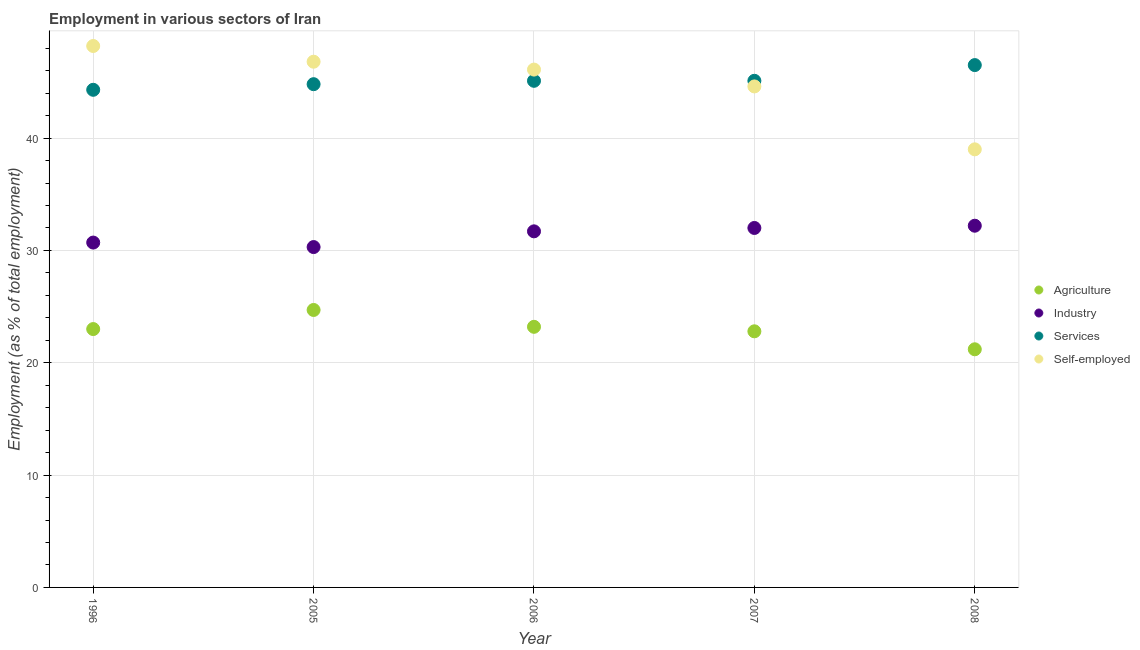Is the number of dotlines equal to the number of legend labels?
Provide a succinct answer. Yes. What is the percentage of workers in services in 2007?
Ensure brevity in your answer.  45.1. Across all years, what is the maximum percentage of workers in agriculture?
Your answer should be compact. 24.7. Across all years, what is the minimum percentage of workers in services?
Your answer should be compact. 44.3. What is the total percentage of workers in agriculture in the graph?
Your answer should be very brief. 114.9. What is the difference between the percentage of workers in services in 1996 and that in 2008?
Provide a succinct answer. -2.2. What is the difference between the percentage of workers in industry in 2006 and the percentage of workers in services in 2008?
Provide a short and direct response. -14.8. What is the average percentage of workers in services per year?
Give a very brief answer. 45.16. In the year 2006, what is the difference between the percentage of workers in services and percentage of workers in industry?
Offer a very short reply. 13.4. In how many years, is the percentage of workers in agriculture greater than 36 %?
Keep it short and to the point. 0. What is the ratio of the percentage of workers in services in 1996 to that in 2006?
Your answer should be compact. 0.98. What is the difference between the highest and the second highest percentage of workers in industry?
Provide a succinct answer. 0.2. What is the difference between the highest and the lowest percentage of workers in industry?
Offer a terse response. 1.9. In how many years, is the percentage of workers in industry greater than the average percentage of workers in industry taken over all years?
Offer a terse response. 3. Is the sum of the percentage of workers in industry in 2005 and 2008 greater than the maximum percentage of self employed workers across all years?
Your response must be concise. Yes. Is it the case that in every year, the sum of the percentage of self employed workers and percentage of workers in industry is greater than the sum of percentage of workers in services and percentage of workers in agriculture?
Offer a terse response. Yes. Is it the case that in every year, the sum of the percentage of workers in agriculture and percentage of workers in industry is greater than the percentage of workers in services?
Give a very brief answer. Yes. How many dotlines are there?
Offer a very short reply. 4. Does the graph contain any zero values?
Give a very brief answer. No. Where does the legend appear in the graph?
Your answer should be very brief. Center right. What is the title of the graph?
Your response must be concise. Employment in various sectors of Iran. Does "WFP" appear as one of the legend labels in the graph?
Provide a succinct answer. No. What is the label or title of the X-axis?
Your answer should be very brief. Year. What is the label or title of the Y-axis?
Keep it short and to the point. Employment (as % of total employment). What is the Employment (as % of total employment) in Industry in 1996?
Provide a succinct answer. 30.7. What is the Employment (as % of total employment) in Services in 1996?
Give a very brief answer. 44.3. What is the Employment (as % of total employment) of Self-employed in 1996?
Your answer should be very brief. 48.2. What is the Employment (as % of total employment) of Agriculture in 2005?
Keep it short and to the point. 24.7. What is the Employment (as % of total employment) of Industry in 2005?
Give a very brief answer. 30.3. What is the Employment (as % of total employment) of Services in 2005?
Offer a terse response. 44.8. What is the Employment (as % of total employment) in Self-employed in 2005?
Your response must be concise. 46.8. What is the Employment (as % of total employment) of Agriculture in 2006?
Provide a short and direct response. 23.2. What is the Employment (as % of total employment) of Industry in 2006?
Provide a short and direct response. 31.7. What is the Employment (as % of total employment) of Services in 2006?
Ensure brevity in your answer.  45.1. What is the Employment (as % of total employment) of Self-employed in 2006?
Provide a short and direct response. 46.1. What is the Employment (as % of total employment) in Agriculture in 2007?
Your response must be concise. 22.8. What is the Employment (as % of total employment) in Services in 2007?
Provide a succinct answer. 45.1. What is the Employment (as % of total employment) of Self-employed in 2007?
Keep it short and to the point. 44.6. What is the Employment (as % of total employment) in Agriculture in 2008?
Ensure brevity in your answer.  21.2. What is the Employment (as % of total employment) in Industry in 2008?
Give a very brief answer. 32.2. What is the Employment (as % of total employment) of Services in 2008?
Offer a terse response. 46.5. Across all years, what is the maximum Employment (as % of total employment) of Agriculture?
Ensure brevity in your answer.  24.7. Across all years, what is the maximum Employment (as % of total employment) of Industry?
Your answer should be compact. 32.2. Across all years, what is the maximum Employment (as % of total employment) of Services?
Offer a terse response. 46.5. Across all years, what is the maximum Employment (as % of total employment) in Self-employed?
Your answer should be compact. 48.2. Across all years, what is the minimum Employment (as % of total employment) in Agriculture?
Give a very brief answer. 21.2. Across all years, what is the minimum Employment (as % of total employment) of Industry?
Provide a succinct answer. 30.3. Across all years, what is the minimum Employment (as % of total employment) of Services?
Give a very brief answer. 44.3. Across all years, what is the minimum Employment (as % of total employment) of Self-employed?
Offer a very short reply. 39. What is the total Employment (as % of total employment) of Agriculture in the graph?
Offer a terse response. 114.9. What is the total Employment (as % of total employment) in Industry in the graph?
Make the answer very short. 156.9. What is the total Employment (as % of total employment) of Services in the graph?
Your response must be concise. 225.8. What is the total Employment (as % of total employment) of Self-employed in the graph?
Provide a succinct answer. 224.7. What is the difference between the Employment (as % of total employment) of Services in 1996 and that in 2005?
Your response must be concise. -0.5. What is the difference between the Employment (as % of total employment) in Self-employed in 1996 and that in 2005?
Provide a succinct answer. 1.4. What is the difference between the Employment (as % of total employment) of Self-employed in 1996 and that in 2006?
Ensure brevity in your answer.  2.1. What is the difference between the Employment (as % of total employment) in Agriculture in 1996 and that in 2007?
Make the answer very short. 0.2. What is the difference between the Employment (as % of total employment) of Agriculture in 1996 and that in 2008?
Give a very brief answer. 1.8. What is the difference between the Employment (as % of total employment) of Industry in 2005 and that in 2006?
Keep it short and to the point. -1.4. What is the difference between the Employment (as % of total employment) of Agriculture in 2005 and that in 2007?
Your response must be concise. 1.9. What is the difference between the Employment (as % of total employment) in Industry in 2005 and that in 2007?
Ensure brevity in your answer.  -1.7. What is the difference between the Employment (as % of total employment) of Self-employed in 2005 and that in 2007?
Provide a succinct answer. 2.2. What is the difference between the Employment (as % of total employment) of Self-employed in 2005 and that in 2008?
Give a very brief answer. 7.8. What is the difference between the Employment (as % of total employment) in Agriculture in 2006 and that in 2007?
Provide a short and direct response. 0.4. What is the difference between the Employment (as % of total employment) in Industry in 2006 and that in 2007?
Your answer should be compact. -0.3. What is the difference between the Employment (as % of total employment) of Self-employed in 2006 and that in 2007?
Provide a short and direct response. 1.5. What is the difference between the Employment (as % of total employment) of Services in 2006 and that in 2008?
Keep it short and to the point. -1.4. What is the difference between the Employment (as % of total employment) in Industry in 2007 and that in 2008?
Make the answer very short. -0.2. What is the difference between the Employment (as % of total employment) in Agriculture in 1996 and the Employment (as % of total employment) in Services in 2005?
Provide a short and direct response. -21.8. What is the difference between the Employment (as % of total employment) of Agriculture in 1996 and the Employment (as % of total employment) of Self-employed in 2005?
Make the answer very short. -23.8. What is the difference between the Employment (as % of total employment) of Industry in 1996 and the Employment (as % of total employment) of Services in 2005?
Offer a terse response. -14.1. What is the difference between the Employment (as % of total employment) of Industry in 1996 and the Employment (as % of total employment) of Self-employed in 2005?
Give a very brief answer. -16.1. What is the difference between the Employment (as % of total employment) in Services in 1996 and the Employment (as % of total employment) in Self-employed in 2005?
Your answer should be compact. -2.5. What is the difference between the Employment (as % of total employment) in Agriculture in 1996 and the Employment (as % of total employment) in Services in 2006?
Ensure brevity in your answer.  -22.1. What is the difference between the Employment (as % of total employment) in Agriculture in 1996 and the Employment (as % of total employment) in Self-employed in 2006?
Your answer should be compact. -23.1. What is the difference between the Employment (as % of total employment) in Industry in 1996 and the Employment (as % of total employment) in Services in 2006?
Provide a succinct answer. -14.4. What is the difference between the Employment (as % of total employment) in Industry in 1996 and the Employment (as % of total employment) in Self-employed in 2006?
Offer a terse response. -15.4. What is the difference between the Employment (as % of total employment) of Services in 1996 and the Employment (as % of total employment) of Self-employed in 2006?
Keep it short and to the point. -1.8. What is the difference between the Employment (as % of total employment) of Agriculture in 1996 and the Employment (as % of total employment) of Services in 2007?
Give a very brief answer. -22.1. What is the difference between the Employment (as % of total employment) of Agriculture in 1996 and the Employment (as % of total employment) of Self-employed in 2007?
Provide a succinct answer. -21.6. What is the difference between the Employment (as % of total employment) in Industry in 1996 and the Employment (as % of total employment) in Services in 2007?
Offer a very short reply. -14.4. What is the difference between the Employment (as % of total employment) of Industry in 1996 and the Employment (as % of total employment) of Self-employed in 2007?
Keep it short and to the point. -13.9. What is the difference between the Employment (as % of total employment) in Services in 1996 and the Employment (as % of total employment) in Self-employed in 2007?
Give a very brief answer. -0.3. What is the difference between the Employment (as % of total employment) in Agriculture in 1996 and the Employment (as % of total employment) in Industry in 2008?
Your response must be concise. -9.2. What is the difference between the Employment (as % of total employment) in Agriculture in 1996 and the Employment (as % of total employment) in Services in 2008?
Provide a short and direct response. -23.5. What is the difference between the Employment (as % of total employment) of Industry in 1996 and the Employment (as % of total employment) of Services in 2008?
Your answer should be compact. -15.8. What is the difference between the Employment (as % of total employment) of Industry in 1996 and the Employment (as % of total employment) of Self-employed in 2008?
Your answer should be compact. -8.3. What is the difference between the Employment (as % of total employment) in Services in 1996 and the Employment (as % of total employment) in Self-employed in 2008?
Your answer should be very brief. 5.3. What is the difference between the Employment (as % of total employment) in Agriculture in 2005 and the Employment (as % of total employment) in Services in 2006?
Provide a succinct answer. -20.4. What is the difference between the Employment (as % of total employment) in Agriculture in 2005 and the Employment (as % of total employment) in Self-employed in 2006?
Provide a short and direct response. -21.4. What is the difference between the Employment (as % of total employment) of Industry in 2005 and the Employment (as % of total employment) of Services in 2006?
Make the answer very short. -14.8. What is the difference between the Employment (as % of total employment) of Industry in 2005 and the Employment (as % of total employment) of Self-employed in 2006?
Make the answer very short. -15.8. What is the difference between the Employment (as % of total employment) in Agriculture in 2005 and the Employment (as % of total employment) in Services in 2007?
Keep it short and to the point. -20.4. What is the difference between the Employment (as % of total employment) of Agriculture in 2005 and the Employment (as % of total employment) of Self-employed in 2007?
Your answer should be compact. -19.9. What is the difference between the Employment (as % of total employment) of Industry in 2005 and the Employment (as % of total employment) of Services in 2007?
Offer a terse response. -14.8. What is the difference between the Employment (as % of total employment) of Industry in 2005 and the Employment (as % of total employment) of Self-employed in 2007?
Provide a succinct answer. -14.3. What is the difference between the Employment (as % of total employment) of Services in 2005 and the Employment (as % of total employment) of Self-employed in 2007?
Provide a succinct answer. 0.2. What is the difference between the Employment (as % of total employment) in Agriculture in 2005 and the Employment (as % of total employment) in Industry in 2008?
Provide a succinct answer. -7.5. What is the difference between the Employment (as % of total employment) in Agriculture in 2005 and the Employment (as % of total employment) in Services in 2008?
Ensure brevity in your answer.  -21.8. What is the difference between the Employment (as % of total employment) of Agriculture in 2005 and the Employment (as % of total employment) of Self-employed in 2008?
Keep it short and to the point. -14.3. What is the difference between the Employment (as % of total employment) in Industry in 2005 and the Employment (as % of total employment) in Services in 2008?
Provide a short and direct response. -16.2. What is the difference between the Employment (as % of total employment) of Industry in 2005 and the Employment (as % of total employment) of Self-employed in 2008?
Ensure brevity in your answer.  -8.7. What is the difference between the Employment (as % of total employment) of Agriculture in 2006 and the Employment (as % of total employment) of Services in 2007?
Your response must be concise. -21.9. What is the difference between the Employment (as % of total employment) in Agriculture in 2006 and the Employment (as % of total employment) in Self-employed in 2007?
Your answer should be very brief. -21.4. What is the difference between the Employment (as % of total employment) of Industry in 2006 and the Employment (as % of total employment) of Self-employed in 2007?
Make the answer very short. -12.9. What is the difference between the Employment (as % of total employment) in Services in 2006 and the Employment (as % of total employment) in Self-employed in 2007?
Offer a very short reply. 0.5. What is the difference between the Employment (as % of total employment) in Agriculture in 2006 and the Employment (as % of total employment) in Industry in 2008?
Offer a very short reply. -9. What is the difference between the Employment (as % of total employment) of Agriculture in 2006 and the Employment (as % of total employment) of Services in 2008?
Offer a terse response. -23.3. What is the difference between the Employment (as % of total employment) of Agriculture in 2006 and the Employment (as % of total employment) of Self-employed in 2008?
Keep it short and to the point. -15.8. What is the difference between the Employment (as % of total employment) of Industry in 2006 and the Employment (as % of total employment) of Services in 2008?
Your response must be concise. -14.8. What is the difference between the Employment (as % of total employment) of Agriculture in 2007 and the Employment (as % of total employment) of Services in 2008?
Give a very brief answer. -23.7. What is the difference between the Employment (as % of total employment) in Agriculture in 2007 and the Employment (as % of total employment) in Self-employed in 2008?
Provide a short and direct response. -16.2. What is the difference between the Employment (as % of total employment) of Services in 2007 and the Employment (as % of total employment) of Self-employed in 2008?
Your response must be concise. 6.1. What is the average Employment (as % of total employment) of Agriculture per year?
Your answer should be very brief. 22.98. What is the average Employment (as % of total employment) in Industry per year?
Ensure brevity in your answer.  31.38. What is the average Employment (as % of total employment) of Services per year?
Make the answer very short. 45.16. What is the average Employment (as % of total employment) of Self-employed per year?
Offer a very short reply. 44.94. In the year 1996, what is the difference between the Employment (as % of total employment) of Agriculture and Employment (as % of total employment) of Services?
Provide a short and direct response. -21.3. In the year 1996, what is the difference between the Employment (as % of total employment) in Agriculture and Employment (as % of total employment) in Self-employed?
Provide a succinct answer. -25.2. In the year 1996, what is the difference between the Employment (as % of total employment) of Industry and Employment (as % of total employment) of Services?
Ensure brevity in your answer.  -13.6. In the year 1996, what is the difference between the Employment (as % of total employment) of Industry and Employment (as % of total employment) of Self-employed?
Your answer should be very brief. -17.5. In the year 2005, what is the difference between the Employment (as % of total employment) of Agriculture and Employment (as % of total employment) of Services?
Make the answer very short. -20.1. In the year 2005, what is the difference between the Employment (as % of total employment) of Agriculture and Employment (as % of total employment) of Self-employed?
Your answer should be compact. -22.1. In the year 2005, what is the difference between the Employment (as % of total employment) of Industry and Employment (as % of total employment) of Services?
Your answer should be very brief. -14.5. In the year 2005, what is the difference between the Employment (as % of total employment) in Industry and Employment (as % of total employment) in Self-employed?
Provide a short and direct response. -16.5. In the year 2006, what is the difference between the Employment (as % of total employment) in Agriculture and Employment (as % of total employment) in Services?
Provide a succinct answer. -21.9. In the year 2006, what is the difference between the Employment (as % of total employment) of Agriculture and Employment (as % of total employment) of Self-employed?
Your response must be concise. -22.9. In the year 2006, what is the difference between the Employment (as % of total employment) of Industry and Employment (as % of total employment) of Self-employed?
Offer a very short reply. -14.4. In the year 2006, what is the difference between the Employment (as % of total employment) of Services and Employment (as % of total employment) of Self-employed?
Offer a terse response. -1. In the year 2007, what is the difference between the Employment (as % of total employment) of Agriculture and Employment (as % of total employment) of Services?
Give a very brief answer. -22.3. In the year 2007, what is the difference between the Employment (as % of total employment) in Agriculture and Employment (as % of total employment) in Self-employed?
Give a very brief answer. -21.8. In the year 2007, what is the difference between the Employment (as % of total employment) in Industry and Employment (as % of total employment) in Services?
Offer a very short reply. -13.1. In the year 2007, what is the difference between the Employment (as % of total employment) in Services and Employment (as % of total employment) in Self-employed?
Keep it short and to the point. 0.5. In the year 2008, what is the difference between the Employment (as % of total employment) of Agriculture and Employment (as % of total employment) of Industry?
Keep it short and to the point. -11. In the year 2008, what is the difference between the Employment (as % of total employment) in Agriculture and Employment (as % of total employment) in Services?
Offer a terse response. -25.3. In the year 2008, what is the difference between the Employment (as % of total employment) of Agriculture and Employment (as % of total employment) of Self-employed?
Provide a short and direct response. -17.8. In the year 2008, what is the difference between the Employment (as % of total employment) in Industry and Employment (as % of total employment) in Services?
Your answer should be very brief. -14.3. What is the ratio of the Employment (as % of total employment) in Agriculture in 1996 to that in 2005?
Your answer should be compact. 0.93. What is the ratio of the Employment (as % of total employment) of Industry in 1996 to that in 2005?
Keep it short and to the point. 1.01. What is the ratio of the Employment (as % of total employment) of Services in 1996 to that in 2005?
Your answer should be compact. 0.99. What is the ratio of the Employment (as % of total employment) of Self-employed in 1996 to that in 2005?
Your answer should be very brief. 1.03. What is the ratio of the Employment (as % of total employment) in Agriculture in 1996 to that in 2006?
Make the answer very short. 0.99. What is the ratio of the Employment (as % of total employment) in Industry in 1996 to that in 2006?
Make the answer very short. 0.97. What is the ratio of the Employment (as % of total employment) in Services in 1996 to that in 2006?
Make the answer very short. 0.98. What is the ratio of the Employment (as % of total employment) of Self-employed in 1996 to that in 2006?
Give a very brief answer. 1.05. What is the ratio of the Employment (as % of total employment) in Agriculture in 1996 to that in 2007?
Provide a succinct answer. 1.01. What is the ratio of the Employment (as % of total employment) of Industry in 1996 to that in 2007?
Your response must be concise. 0.96. What is the ratio of the Employment (as % of total employment) of Services in 1996 to that in 2007?
Make the answer very short. 0.98. What is the ratio of the Employment (as % of total employment) of Self-employed in 1996 to that in 2007?
Keep it short and to the point. 1.08. What is the ratio of the Employment (as % of total employment) in Agriculture in 1996 to that in 2008?
Provide a succinct answer. 1.08. What is the ratio of the Employment (as % of total employment) in Industry in 1996 to that in 2008?
Ensure brevity in your answer.  0.95. What is the ratio of the Employment (as % of total employment) of Services in 1996 to that in 2008?
Make the answer very short. 0.95. What is the ratio of the Employment (as % of total employment) of Self-employed in 1996 to that in 2008?
Give a very brief answer. 1.24. What is the ratio of the Employment (as % of total employment) of Agriculture in 2005 to that in 2006?
Provide a short and direct response. 1.06. What is the ratio of the Employment (as % of total employment) of Industry in 2005 to that in 2006?
Give a very brief answer. 0.96. What is the ratio of the Employment (as % of total employment) in Services in 2005 to that in 2006?
Your answer should be compact. 0.99. What is the ratio of the Employment (as % of total employment) of Self-employed in 2005 to that in 2006?
Ensure brevity in your answer.  1.02. What is the ratio of the Employment (as % of total employment) of Industry in 2005 to that in 2007?
Give a very brief answer. 0.95. What is the ratio of the Employment (as % of total employment) in Services in 2005 to that in 2007?
Make the answer very short. 0.99. What is the ratio of the Employment (as % of total employment) of Self-employed in 2005 to that in 2007?
Your answer should be compact. 1.05. What is the ratio of the Employment (as % of total employment) of Agriculture in 2005 to that in 2008?
Offer a terse response. 1.17. What is the ratio of the Employment (as % of total employment) in Industry in 2005 to that in 2008?
Give a very brief answer. 0.94. What is the ratio of the Employment (as % of total employment) in Services in 2005 to that in 2008?
Your answer should be very brief. 0.96. What is the ratio of the Employment (as % of total employment) in Self-employed in 2005 to that in 2008?
Ensure brevity in your answer.  1.2. What is the ratio of the Employment (as % of total employment) of Agriculture in 2006 to that in 2007?
Offer a very short reply. 1.02. What is the ratio of the Employment (as % of total employment) of Industry in 2006 to that in 2007?
Give a very brief answer. 0.99. What is the ratio of the Employment (as % of total employment) of Services in 2006 to that in 2007?
Provide a succinct answer. 1. What is the ratio of the Employment (as % of total employment) in Self-employed in 2006 to that in 2007?
Your answer should be very brief. 1.03. What is the ratio of the Employment (as % of total employment) of Agriculture in 2006 to that in 2008?
Make the answer very short. 1.09. What is the ratio of the Employment (as % of total employment) in Industry in 2006 to that in 2008?
Offer a terse response. 0.98. What is the ratio of the Employment (as % of total employment) of Services in 2006 to that in 2008?
Provide a succinct answer. 0.97. What is the ratio of the Employment (as % of total employment) of Self-employed in 2006 to that in 2008?
Offer a terse response. 1.18. What is the ratio of the Employment (as % of total employment) of Agriculture in 2007 to that in 2008?
Offer a very short reply. 1.08. What is the ratio of the Employment (as % of total employment) in Services in 2007 to that in 2008?
Provide a succinct answer. 0.97. What is the ratio of the Employment (as % of total employment) in Self-employed in 2007 to that in 2008?
Offer a terse response. 1.14. What is the difference between the highest and the second highest Employment (as % of total employment) in Self-employed?
Your answer should be very brief. 1.4. What is the difference between the highest and the lowest Employment (as % of total employment) in Industry?
Provide a short and direct response. 1.9. What is the difference between the highest and the lowest Employment (as % of total employment) of Services?
Provide a succinct answer. 2.2. What is the difference between the highest and the lowest Employment (as % of total employment) in Self-employed?
Your answer should be very brief. 9.2. 